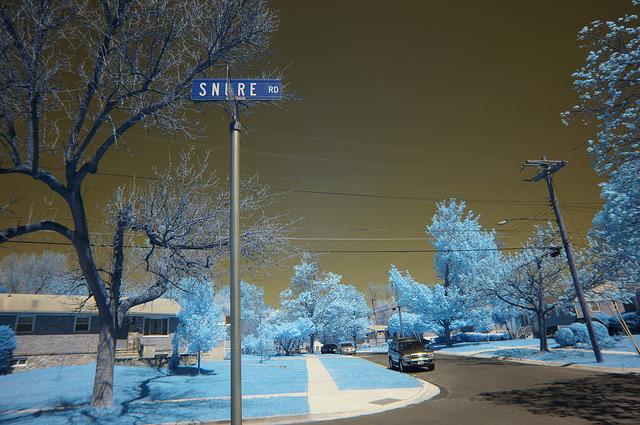How many cars are on the street?
Keep it brief. 1. Is this a beach?
Write a very short answer. No. Is this in America?
Concise answer only. Yes. Have the colors in this shot been tampered with?
Quick response, please. Yes. How many power poles are visible?
Keep it brief. 1. 